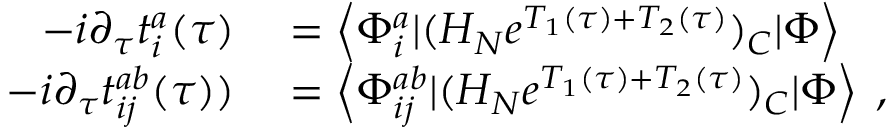Convert formula to latex. <formula><loc_0><loc_0><loc_500><loc_500>\begin{array} { r l } { - i \partial _ { \tau } t _ { i } ^ { a } ( \tau ) } & = \left < \Phi _ { i } ^ { a } | ( H _ { N } e ^ { T _ { 1 } ( \tau ) + T _ { 2 } ( \tau ) } ) _ { C } | \Phi \right > } \\ { - i \partial _ { \tau } t _ { i j } ^ { a b } ( \tau ) ) } & = \left < \Phi _ { i j } ^ { a b } | ( H _ { N } e ^ { T _ { 1 } ( \tau ) + T _ { 2 } ( \tau ) } ) _ { C } | \Phi \right > \, , } \end{array}</formula> 